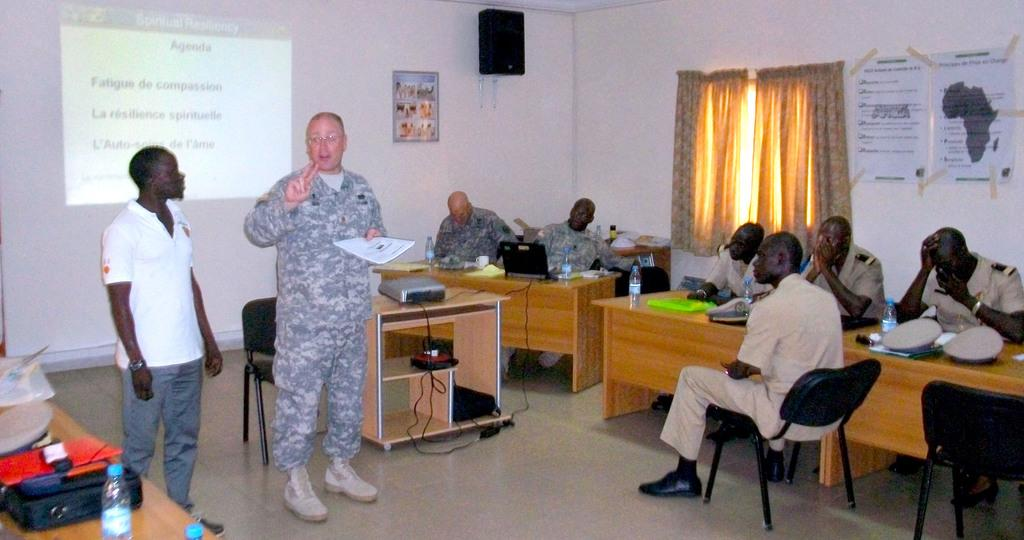<image>
Describe the image concisely. A military man goes over the agenda with a group of men. 